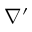<formula> <loc_0><loc_0><loc_500><loc_500>\nabla ^ { \prime }</formula> 